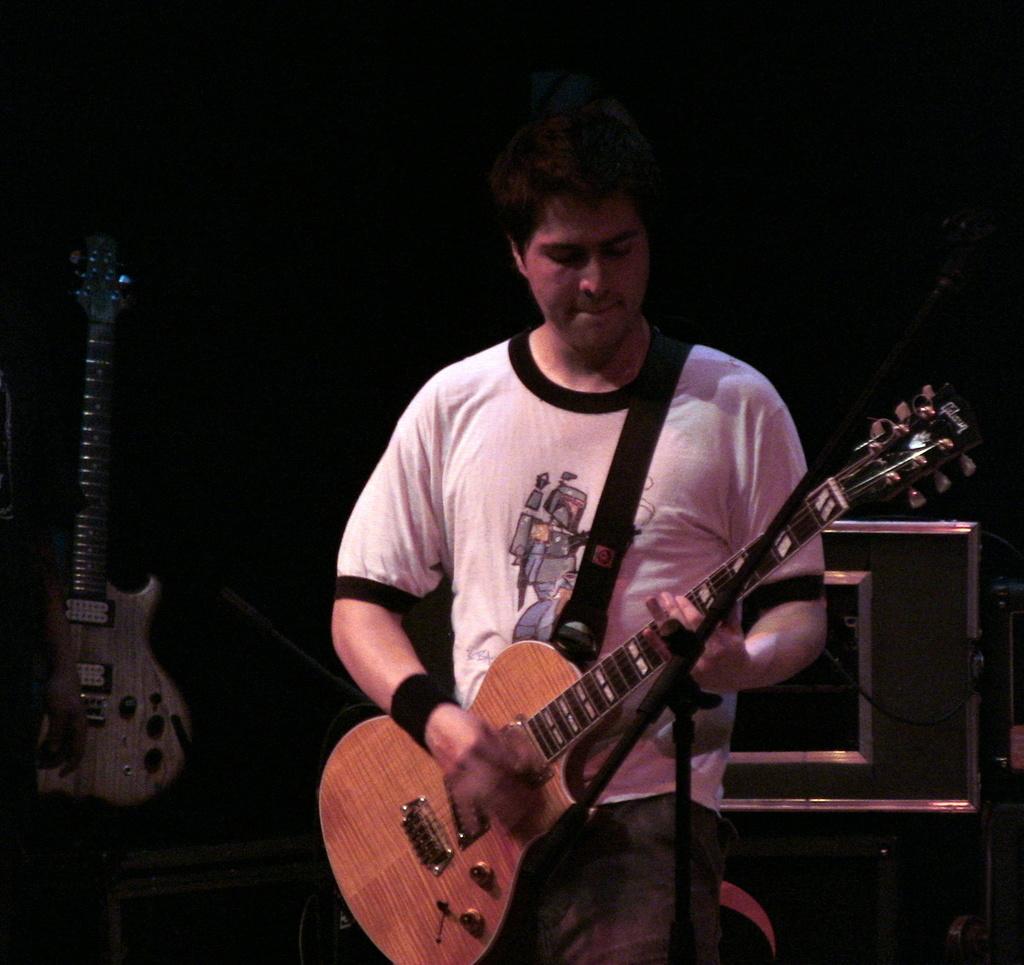Please provide a concise description of this image. In this picture there is a person who is standing at the center of the image, by holding the guitar in his hands and there is another guitar at the left side of the image. 